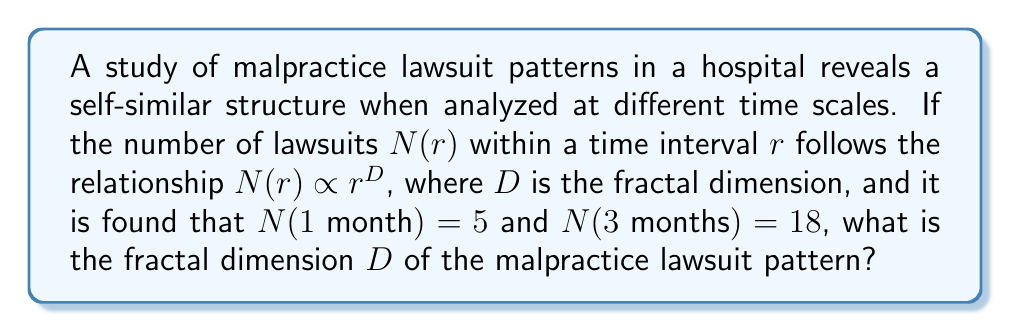Can you answer this question? To solve this problem, we'll use the fractal dimension formula and the given data:

1) The fractal dimension $D$ is defined by the relationship:
   $$N(r) \propto r^D$$

2) This can be written as:
   $$N(r) = kr^D$$
   where $k$ is a constant.

3) We have two data points:
   $N(1) = 5$ and $N(3) = 18$

4) Substituting these into the equation:
   $$5 = k(1)^D$$
   $$18 = k(3)^D$$

5) Dividing the second equation by the first:
   $$\frac{18}{5} = \frac{k(3)^D}{k(1)^D} = 3^D$$

6) Taking the logarithm of both sides:
   $$\log(\frac{18}{5}) = D \log(3)$$

7) Solving for $D$:
   $$D = \frac{\log(\frac{18}{5})}{\log(3)} \approx 1.7603$$

This fractal dimension indicates that the pattern of malpractice lawsuits fills more space than a line (dimension 1) but less than a plane (dimension 2), suggesting a complex, potentially chaotic pattern over time.
Answer: $D \approx 1.7603$ 